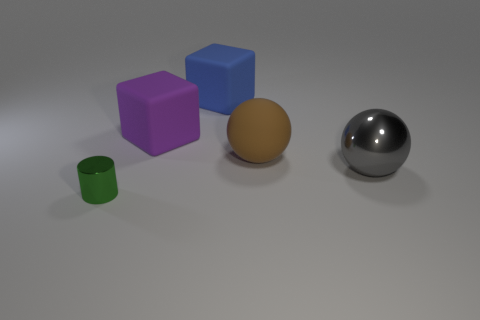Add 2 brown metal cubes. How many objects exist? 7 Subtract all balls. How many objects are left? 3 Add 5 big blue cubes. How many big blue cubes are left? 6 Add 4 big blue rubber objects. How many big blue rubber objects exist? 5 Subtract 0 yellow spheres. How many objects are left? 5 Subtract all green metal cylinders. Subtract all small cylinders. How many objects are left? 3 